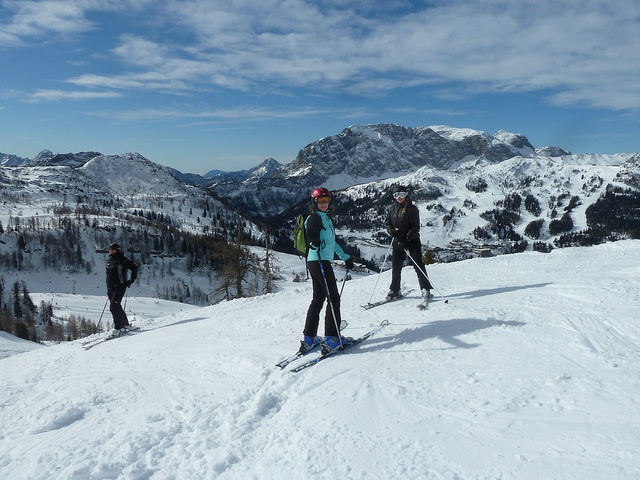Describe the objects in this image and their specific colors. I can see people in gray, black, and teal tones, people in gray, black, lightgray, and darkgray tones, people in gray, black, and darkblue tones, skis in gray, darkgray, navy, and lightgray tones, and backpack in gray, black, and darkgreen tones in this image. 